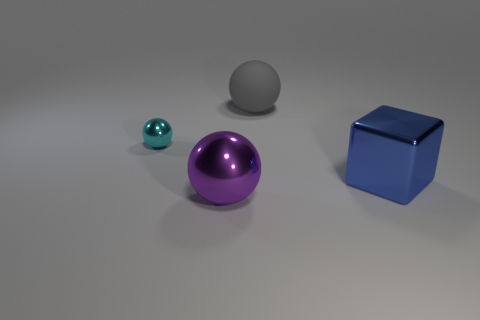Does the cyan object have the same material as the blue thing?
Ensure brevity in your answer.  Yes. Is the number of metal things on the right side of the cyan metal thing greater than the number of tiny metallic things?
Provide a short and direct response. Yes. What number of objects are big purple metallic objects or things on the left side of the gray object?
Keep it short and to the point. 2. Are there more large blue metallic cubes in front of the big gray sphere than rubber things that are in front of the purple metal thing?
Your answer should be very brief. Yes. What is the material of the large object to the right of the big ball behind the metallic sphere left of the purple metal sphere?
Provide a succinct answer. Metal. What is the shape of the big blue thing that is made of the same material as the purple ball?
Keep it short and to the point. Cube. There is a ball to the left of the purple metallic sphere; are there any balls that are in front of it?
Ensure brevity in your answer.  Yes. What size is the cyan ball?
Offer a terse response. Small. What number of things are small shiny objects or large brown metal spheres?
Offer a terse response. 1. Is the material of the big object behind the small cyan sphere the same as the thing that is on the left side of the large purple sphere?
Ensure brevity in your answer.  No. 